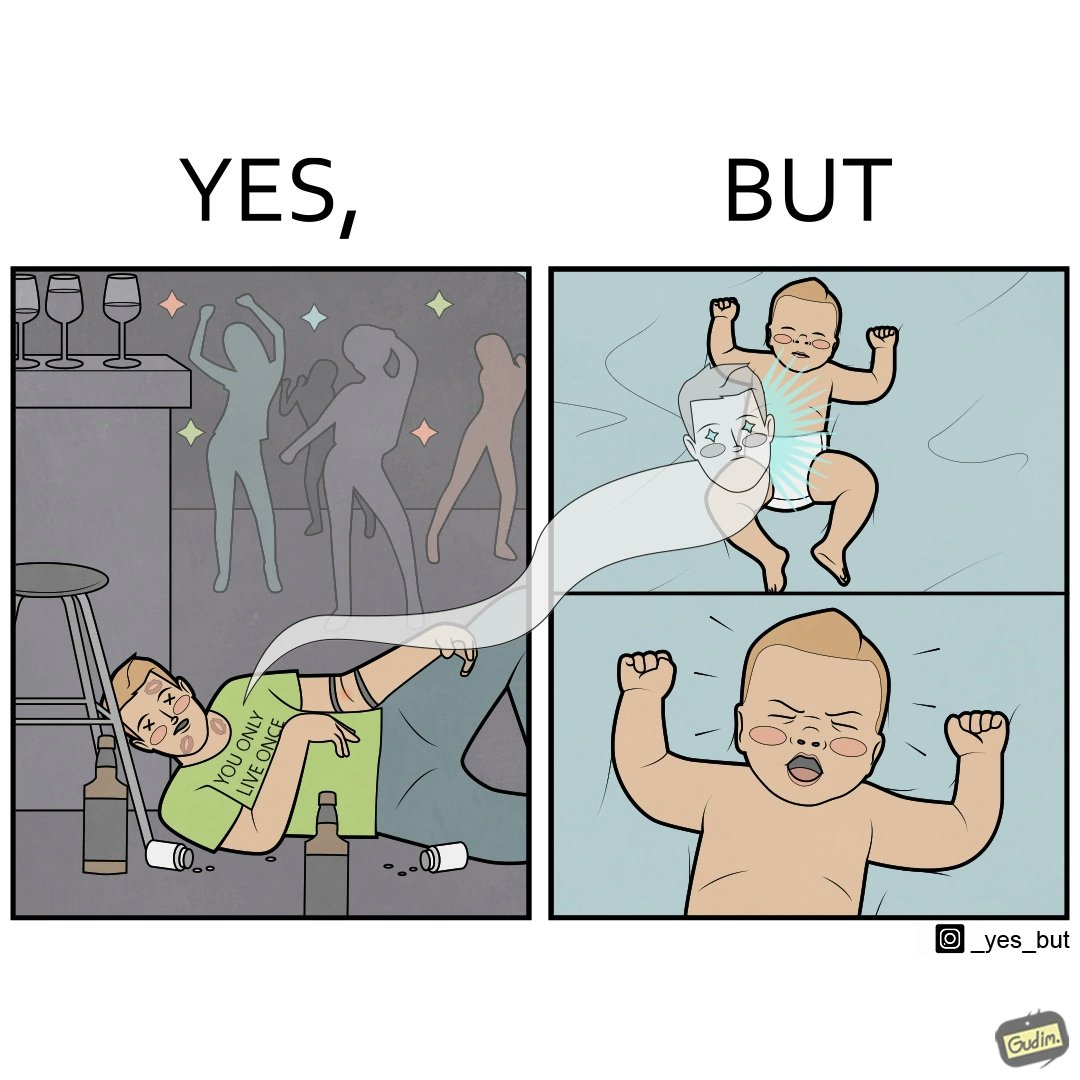Does this image contain satire or humor? Yes, this image is satirical. 